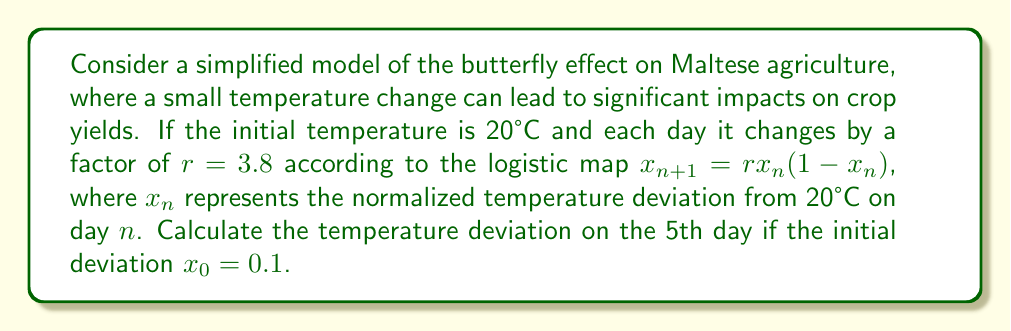Can you solve this math problem? To solve this problem, we need to apply the logistic map equation iteratively for 5 days:

1) Initial condition: $x_0 = 0.1$

2) Day 1: $x_1 = r \cdot x_0 \cdot (1-x_0)$
   $x_1 = 3.8 \cdot 0.1 \cdot (1-0.1) = 0.342$

3) Day 2: $x_2 = r \cdot x_1 \cdot (1-x_1)$
   $x_2 = 3.8 \cdot 0.342 \cdot (1-0.342) = 0.855876$

4) Day 3: $x_3 = r \cdot x_2 \cdot (1-x_2)$
   $x_3 = 3.8 \cdot 0.855876 \cdot (1-0.855876) = 0.468944$

5) Day 4: $x_4 = r \cdot x_3 \cdot (1-x_3)$
   $x_4 = 3.8 \cdot 0.468944 \cdot (1-0.468944) = 0.945582$

6) Day 5: $x_5 = r \cdot x_4 \cdot (1-x_4)$
   $x_5 = 3.8 \cdot 0.945582 \cdot (1-0.945582) = 0.196226$

The normalized temperature deviation on the 5th day is approximately 0.196226. To convert this back to the actual temperature deviation, we multiply by the temperature range (let's assume it's 10°C for simplicity):

Actual temperature deviation = $0.196226 \cdot 10°C = 1.96226°C$

Therefore, the temperature on the 5th day would be approximately 21.96°C.
Answer: 1.96°C above the initial temperature 